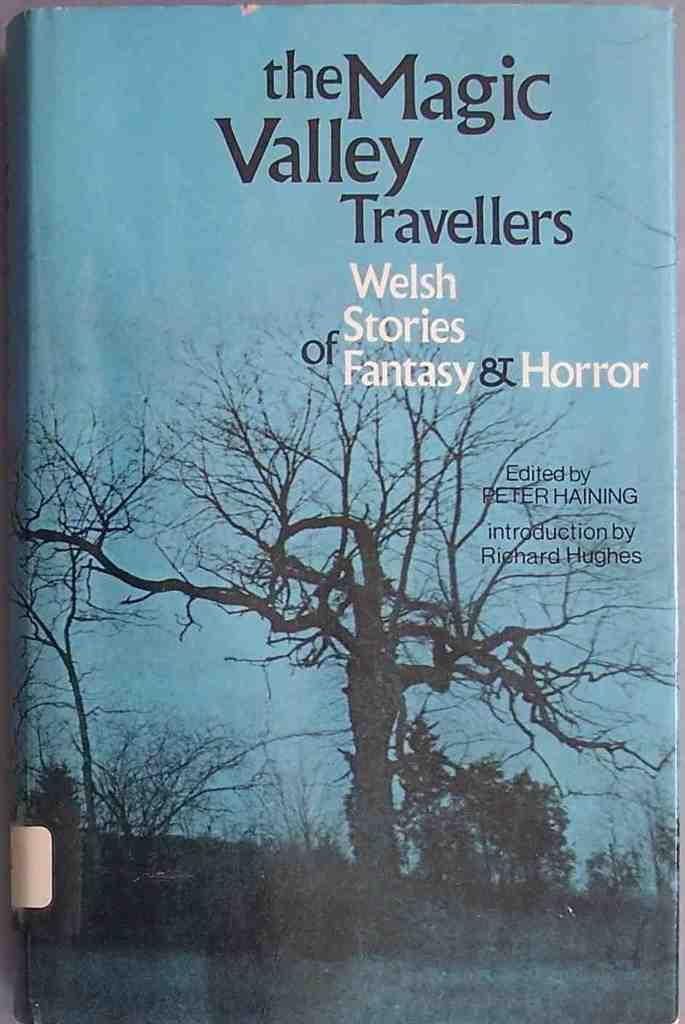<image>
Create a compact narrative representing the image presented. A blue book with a barren tree on it is titled the Magic Valley Travellers. 